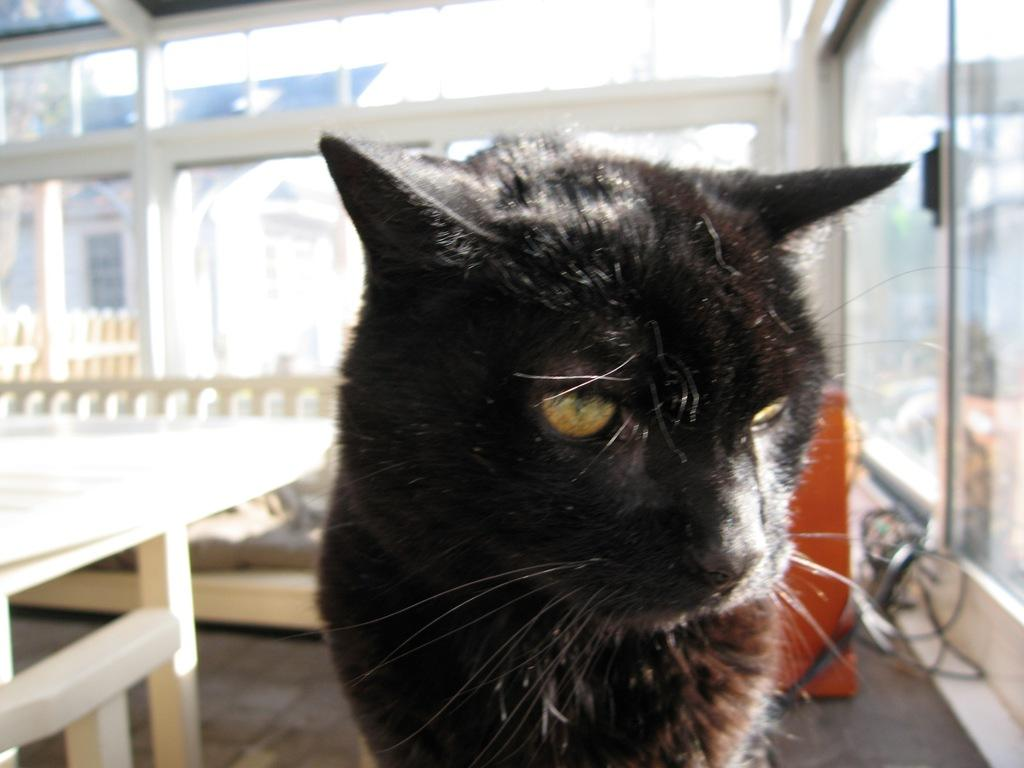What is the main subject in the center of the image? There is a cat in the center of the image. Can you describe the appearance of the cat? The cat is black in color. What is located on the left side of the image? There is a table on the left side of the image. What can be seen in the background of the image? There is a door visible in the background, as well as a sofa. What type of toy is the cat playing with in the image? There is no toy present in the image; the cat is simply sitting in the center. 